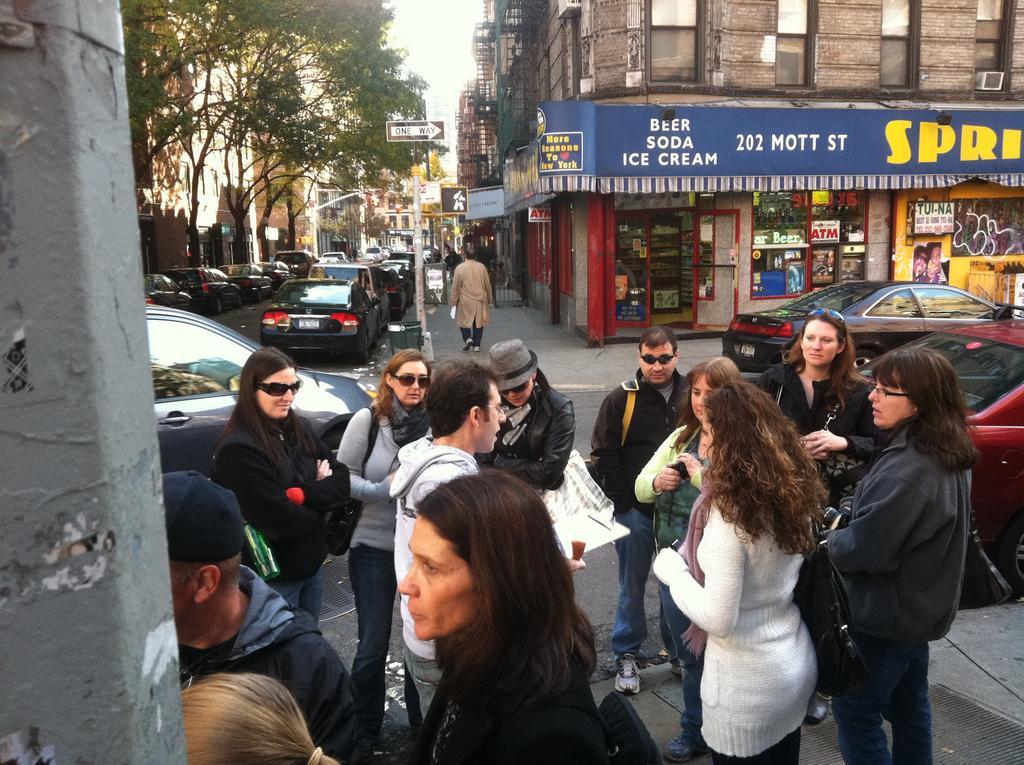Please provide a concise description of this image. In this picture we can see a group of people on the ground,here we can see vehicles,buildings and trees. 